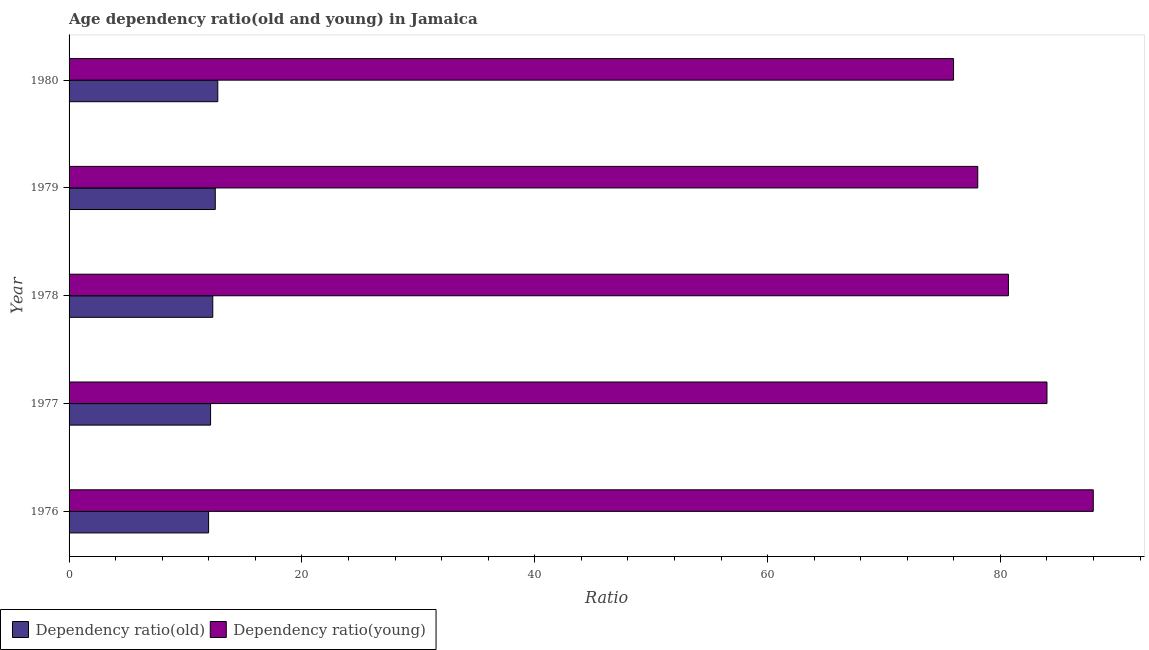How many groups of bars are there?
Your response must be concise. 5. Are the number of bars per tick equal to the number of legend labels?
Provide a succinct answer. Yes. Are the number of bars on each tick of the Y-axis equal?
Keep it short and to the point. Yes. How many bars are there on the 1st tick from the top?
Give a very brief answer. 2. How many bars are there on the 2nd tick from the bottom?
Offer a very short reply. 2. What is the label of the 5th group of bars from the top?
Make the answer very short. 1976. In how many cases, is the number of bars for a given year not equal to the number of legend labels?
Provide a short and direct response. 0. What is the age dependency ratio(young) in 1978?
Offer a very short reply. 80.69. Across all years, what is the maximum age dependency ratio(old)?
Keep it short and to the point. 12.77. Across all years, what is the minimum age dependency ratio(young)?
Provide a short and direct response. 75.97. In which year was the age dependency ratio(young) minimum?
Your response must be concise. 1980. What is the total age dependency ratio(young) in the graph?
Ensure brevity in your answer.  406.69. What is the difference between the age dependency ratio(old) in 1977 and that in 1978?
Offer a terse response. -0.19. What is the difference between the age dependency ratio(young) in 1976 and the age dependency ratio(old) in 1978?
Give a very brief answer. 75.63. What is the average age dependency ratio(young) per year?
Ensure brevity in your answer.  81.34. In the year 1979, what is the difference between the age dependency ratio(young) and age dependency ratio(old)?
Keep it short and to the point. 65.5. In how many years, is the age dependency ratio(old) greater than 44 ?
Your answer should be compact. 0. What is the ratio of the age dependency ratio(young) in 1977 to that in 1978?
Provide a short and direct response. 1.04. What is the difference between the highest and the second highest age dependency ratio(old)?
Your response must be concise. 0.22. What is the difference between the highest and the lowest age dependency ratio(old)?
Make the answer very short. 0.79. Is the sum of the age dependency ratio(old) in 1978 and 1979 greater than the maximum age dependency ratio(young) across all years?
Keep it short and to the point. No. What does the 2nd bar from the top in 1979 represents?
Your response must be concise. Dependency ratio(old). What does the 1st bar from the bottom in 1979 represents?
Offer a very short reply. Dependency ratio(old). How many bars are there?
Give a very brief answer. 10. Are all the bars in the graph horizontal?
Provide a short and direct response. Yes. How many years are there in the graph?
Offer a terse response. 5. Are the values on the major ticks of X-axis written in scientific E-notation?
Your answer should be very brief. No. What is the title of the graph?
Provide a short and direct response. Age dependency ratio(old and young) in Jamaica. What is the label or title of the X-axis?
Offer a terse response. Ratio. What is the Ratio of Dependency ratio(old) in 1976?
Offer a very short reply. 11.98. What is the Ratio in Dependency ratio(young) in 1976?
Your response must be concise. 87.98. What is the Ratio in Dependency ratio(old) in 1977?
Provide a short and direct response. 12.16. What is the Ratio of Dependency ratio(young) in 1977?
Keep it short and to the point. 84. What is the Ratio in Dependency ratio(old) in 1978?
Give a very brief answer. 12.34. What is the Ratio in Dependency ratio(young) in 1978?
Keep it short and to the point. 80.69. What is the Ratio in Dependency ratio(old) in 1979?
Your answer should be very brief. 12.56. What is the Ratio in Dependency ratio(young) in 1979?
Keep it short and to the point. 78.05. What is the Ratio in Dependency ratio(old) in 1980?
Offer a terse response. 12.77. What is the Ratio in Dependency ratio(young) in 1980?
Offer a terse response. 75.97. Across all years, what is the maximum Ratio of Dependency ratio(old)?
Offer a very short reply. 12.77. Across all years, what is the maximum Ratio in Dependency ratio(young)?
Your answer should be compact. 87.98. Across all years, what is the minimum Ratio in Dependency ratio(old)?
Your answer should be very brief. 11.98. Across all years, what is the minimum Ratio of Dependency ratio(young)?
Give a very brief answer. 75.97. What is the total Ratio in Dependency ratio(old) in the graph?
Your answer should be compact. 61.81. What is the total Ratio of Dependency ratio(young) in the graph?
Provide a succinct answer. 406.69. What is the difference between the Ratio in Dependency ratio(old) in 1976 and that in 1977?
Keep it short and to the point. -0.17. What is the difference between the Ratio in Dependency ratio(young) in 1976 and that in 1977?
Give a very brief answer. 3.98. What is the difference between the Ratio in Dependency ratio(old) in 1976 and that in 1978?
Provide a short and direct response. -0.36. What is the difference between the Ratio of Dependency ratio(young) in 1976 and that in 1978?
Ensure brevity in your answer.  7.29. What is the difference between the Ratio of Dependency ratio(old) in 1976 and that in 1979?
Ensure brevity in your answer.  -0.57. What is the difference between the Ratio of Dependency ratio(young) in 1976 and that in 1979?
Offer a very short reply. 9.92. What is the difference between the Ratio of Dependency ratio(old) in 1976 and that in 1980?
Your response must be concise. -0.79. What is the difference between the Ratio in Dependency ratio(young) in 1976 and that in 1980?
Give a very brief answer. 12. What is the difference between the Ratio of Dependency ratio(old) in 1977 and that in 1978?
Your answer should be compact. -0.19. What is the difference between the Ratio of Dependency ratio(young) in 1977 and that in 1978?
Your answer should be compact. 3.31. What is the difference between the Ratio of Dependency ratio(old) in 1977 and that in 1979?
Make the answer very short. -0.4. What is the difference between the Ratio in Dependency ratio(young) in 1977 and that in 1979?
Offer a terse response. 5.94. What is the difference between the Ratio of Dependency ratio(old) in 1977 and that in 1980?
Provide a succinct answer. -0.62. What is the difference between the Ratio in Dependency ratio(young) in 1977 and that in 1980?
Provide a short and direct response. 8.02. What is the difference between the Ratio of Dependency ratio(old) in 1978 and that in 1979?
Offer a terse response. -0.21. What is the difference between the Ratio of Dependency ratio(young) in 1978 and that in 1979?
Give a very brief answer. 2.63. What is the difference between the Ratio in Dependency ratio(old) in 1978 and that in 1980?
Give a very brief answer. -0.43. What is the difference between the Ratio in Dependency ratio(young) in 1978 and that in 1980?
Give a very brief answer. 4.71. What is the difference between the Ratio of Dependency ratio(old) in 1979 and that in 1980?
Give a very brief answer. -0.22. What is the difference between the Ratio in Dependency ratio(young) in 1979 and that in 1980?
Give a very brief answer. 2.08. What is the difference between the Ratio of Dependency ratio(old) in 1976 and the Ratio of Dependency ratio(young) in 1977?
Your answer should be compact. -72.01. What is the difference between the Ratio in Dependency ratio(old) in 1976 and the Ratio in Dependency ratio(young) in 1978?
Make the answer very short. -68.7. What is the difference between the Ratio of Dependency ratio(old) in 1976 and the Ratio of Dependency ratio(young) in 1979?
Offer a terse response. -66.07. What is the difference between the Ratio in Dependency ratio(old) in 1976 and the Ratio in Dependency ratio(young) in 1980?
Your answer should be compact. -63.99. What is the difference between the Ratio in Dependency ratio(old) in 1977 and the Ratio in Dependency ratio(young) in 1978?
Ensure brevity in your answer.  -68.53. What is the difference between the Ratio of Dependency ratio(old) in 1977 and the Ratio of Dependency ratio(young) in 1979?
Your response must be concise. -65.9. What is the difference between the Ratio of Dependency ratio(old) in 1977 and the Ratio of Dependency ratio(young) in 1980?
Keep it short and to the point. -63.82. What is the difference between the Ratio in Dependency ratio(old) in 1978 and the Ratio in Dependency ratio(young) in 1979?
Offer a terse response. -65.71. What is the difference between the Ratio in Dependency ratio(old) in 1978 and the Ratio in Dependency ratio(young) in 1980?
Offer a very short reply. -63.63. What is the difference between the Ratio of Dependency ratio(old) in 1979 and the Ratio of Dependency ratio(young) in 1980?
Your answer should be compact. -63.42. What is the average Ratio in Dependency ratio(old) per year?
Provide a short and direct response. 12.36. What is the average Ratio of Dependency ratio(young) per year?
Your answer should be compact. 81.34. In the year 1976, what is the difference between the Ratio of Dependency ratio(old) and Ratio of Dependency ratio(young)?
Provide a short and direct response. -75.99. In the year 1977, what is the difference between the Ratio in Dependency ratio(old) and Ratio in Dependency ratio(young)?
Offer a terse response. -71.84. In the year 1978, what is the difference between the Ratio in Dependency ratio(old) and Ratio in Dependency ratio(young)?
Give a very brief answer. -68.34. In the year 1979, what is the difference between the Ratio of Dependency ratio(old) and Ratio of Dependency ratio(young)?
Your answer should be compact. -65.5. In the year 1980, what is the difference between the Ratio of Dependency ratio(old) and Ratio of Dependency ratio(young)?
Offer a terse response. -63.2. What is the ratio of the Ratio in Dependency ratio(old) in 1976 to that in 1977?
Ensure brevity in your answer.  0.99. What is the ratio of the Ratio of Dependency ratio(young) in 1976 to that in 1977?
Your answer should be very brief. 1.05. What is the ratio of the Ratio of Dependency ratio(young) in 1976 to that in 1978?
Provide a short and direct response. 1.09. What is the ratio of the Ratio of Dependency ratio(old) in 1976 to that in 1979?
Make the answer very short. 0.95. What is the ratio of the Ratio of Dependency ratio(young) in 1976 to that in 1979?
Keep it short and to the point. 1.13. What is the ratio of the Ratio of Dependency ratio(old) in 1976 to that in 1980?
Your answer should be compact. 0.94. What is the ratio of the Ratio of Dependency ratio(young) in 1976 to that in 1980?
Keep it short and to the point. 1.16. What is the ratio of the Ratio of Dependency ratio(young) in 1977 to that in 1978?
Provide a succinct answer. 1.04. What is the ratio of the Ratio of Dependency ratio(old) in 1977 to that in 1979?
Make the answer very short. 0.97. What is the ratio of the Ratio in Dependency ratio(young) in 1977 to that in 1979?
Keep it short and to the point. 1.08. What is the ratio of the Ratio of Dependency ratio(old) in 1977 to that in 1980?
Keep it short and to the point. 0.95. What is the ratio of the Ratio of Dependency ratio(young) in 1977 to that in 1980?
Give a very brief answer. 1.11. What is the ratio of the Ratio of Dependency ratio(old) in 1978 to that in 1979?
Your answer should be very brief. 0.98. What is the ratio of the Ratio of Dependency ratio(young) in 1978 to that in 1979?
Your response must be concise. 1.03. What is the ratio of the Ratio of Dependency ratio(old) in 1978 to that in 1980?
Offer a terse response. 0.97. What is the ratio of the Ratio in Dependency ratio(young) in 1978 to that in 1980?
Your answer should be compact. 1.06. What is the ratio of the Ratio of Dependency ratio(old) in 1979 to that in 1980?
Give a very brief answer. 0.98. What is the ratio of the Ratio of Dependency ratio(young) in 1979 to that in 1980?
Your answer should be very brief. 1.03. What is the difference between the highest and the second highest Ratio in Dependency ratio(old)?
Ensure brevity in your answer.  0.22. What is the difference between the highest and the second highest Ratio in Dependency ratio(young)?
Make the answer very short. 3.98. What is the difference between the highest and the lowest Ratio of Dependency ratio(old)?
Your answer should be very brief. 0.79. What is the difference between the highest and the lowest Ratio in Dependency ratio(young)?
Give a very brief answer. 12. 